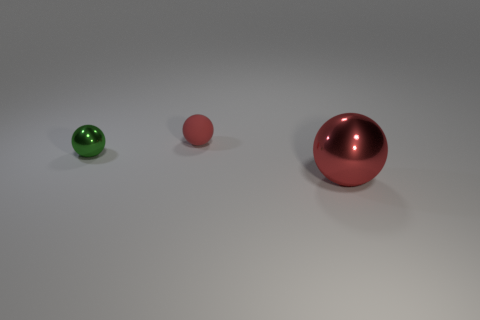There is a large metal object; is it the same color as the metal object to the left of the matte thing?
Your response must be concise. No. Is there any other thing that is made of the same material as the big red sphere?
Provide a succinct answer. Yes. There is a shiny ball that is to the left of the red ball to the right of the small red matte object; what is its size?
Offer a terse response. Small. Are there an equal number of big metallic balls behind the red metallic sphere and green shiny objects on the left side of the tiny green thing?
Make the answer very short. Yes. There is a sphere that is behind the large object and in front of the red matte object; what is it made of?
Offer a terse response. Metal. Do the red rubber object and the metallic sphere that is on the left side of the small red sphere have the same size?
Your answer should be very brief. Yes. How many other things are the same color as the rubber ball?
Keep it short and to the point. 1. Is the number of rubber objects on the right side of the green ball greater than the number of large red balls?
Your answer should be compact. No. There is a metallic ball that is behind the shiny thing right of the shiny thing that is on the left side of the small rubber ball; what color is it?
Ensure brevity in your answer.  Green. Is the material of the green thing the same as the tiny red thing?
Offer a very short reply. No. 